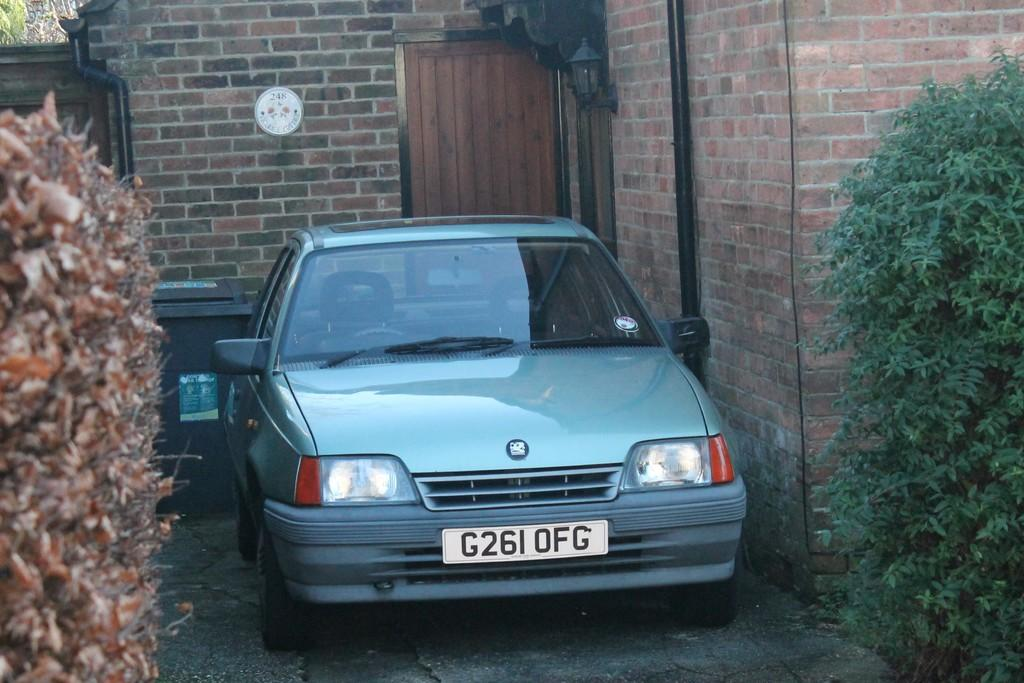What type of vehicle is on the ground in the image? There is a car on the ground in the image. What is the purpose of the bin in the image? The purpose of the bin is not specified in the image, but it is likely for waste disposal. What are the pipes used for in the image? The purpose of the pipes is not specified in the image, but they are likely for transporting fluids or gases. What is the door used for in the image? The door is likely used for entering or exiting a building or room. What is the wall used for in the image? The wall is likely used for providing support and structure to a building or room. What type of vegetation is present in the image? There are trees present in the image. Can you tell me how many people are sleeping in the car in the image? There is no indication of anyone sleeping in the car in the image. What type of tank is visible in the image? There is no tank present in the image. 